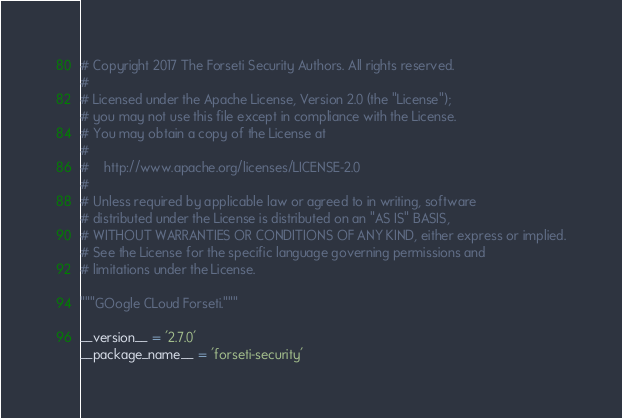Convert code to text. <code><loc_0><loc_0><loc_500><loc_500><_Python_># Copyright 2017 The Forseti Security Authors. All rights reserved.
#
# Licensed under the Apache License, Version 2.0 (the "License");
# you may not use this file except in compliance with the License.
# You may obtain a copy of the License at
#
#    http://www.apache.org/licenses/LICENSE-2.0
#
# Unless required by applicable law or agreed to in writing, software
# distributed under the License is distributed on an "AS IS" BASIS,
# WITHOUT WARRANTIES OR CONDITIONS OF ANY KIND, either express or implied.
# See the License for the specific language governing permissions and
# limitations under the License.

"""GOogle CLoud Forseti."""

__version__ = '2.7.0'
__package_name__ = 'forseti-security'
</code> 